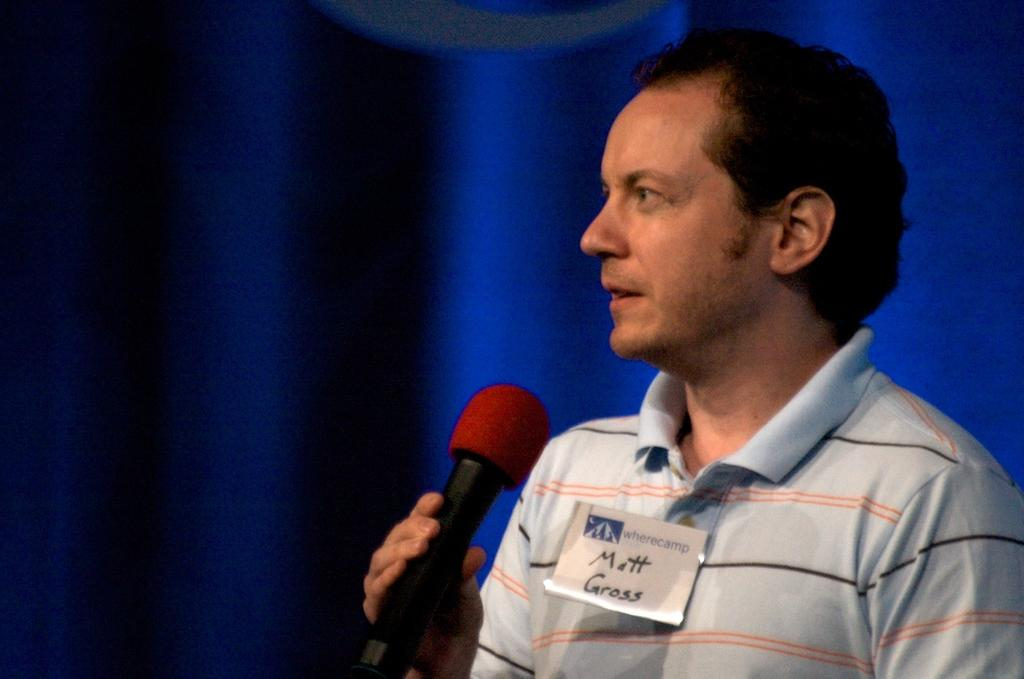What is the main subject of the image? There is a man in the image. What is the man doing in the image? The man is standing in the image. What object is the man holding in his hand? The man is holding a mic in his hand. How many cats are sitting on the plane in the image? There is no plane or cats present in the image. What type of glove is the man wearing in the image? The man is not wearing a glove in the image. 